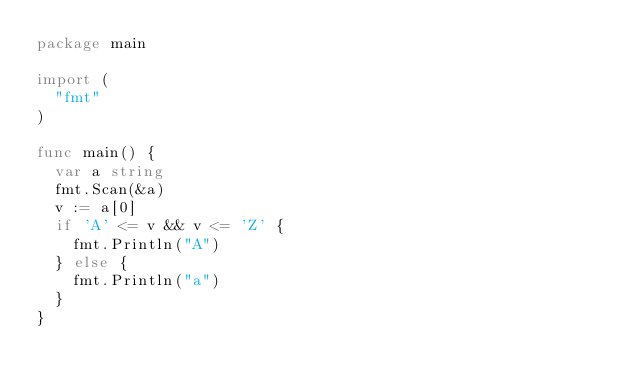<code> <loc_0><loc_0><loc_500><loc_500><_Go_>package main

import (
	"fmt"
)

func main() {
	var a string
	fmt.Scan(&a)
	v := a[0]
	if 'A' <= v && v <= 'Z' {
		fmt.Println("A")
	} else {
		fmt.Println("a")
	}
}
</code> 